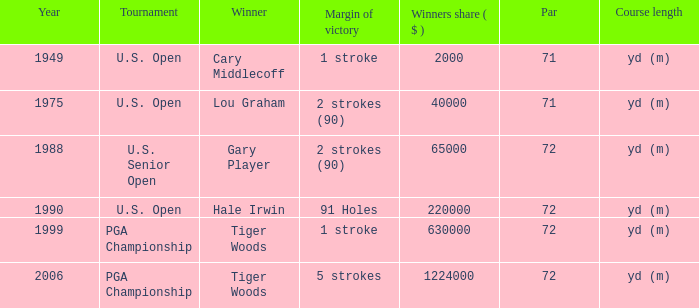When cary middlecoff wins, what is the total number of pars? 1.0. 